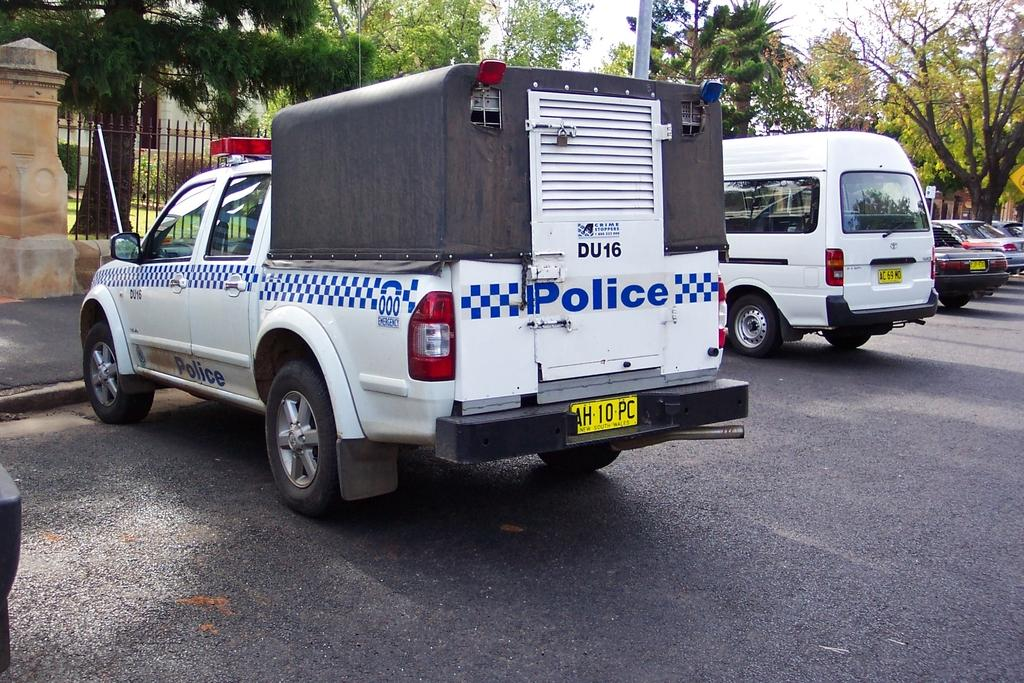What can be seen in the middle of the image? There are vehicles parked on the road in the image. Where are the vehicles located in relation to the image? The vehicles are in the middle of the image. What can be seen in the background of the image? There are trees and a building in the background of the image. How many chickens are sitting on the roof of the building in the image? There are no chickens present in the image; it only features vehicles parked on the road and trees and a building in the background. 